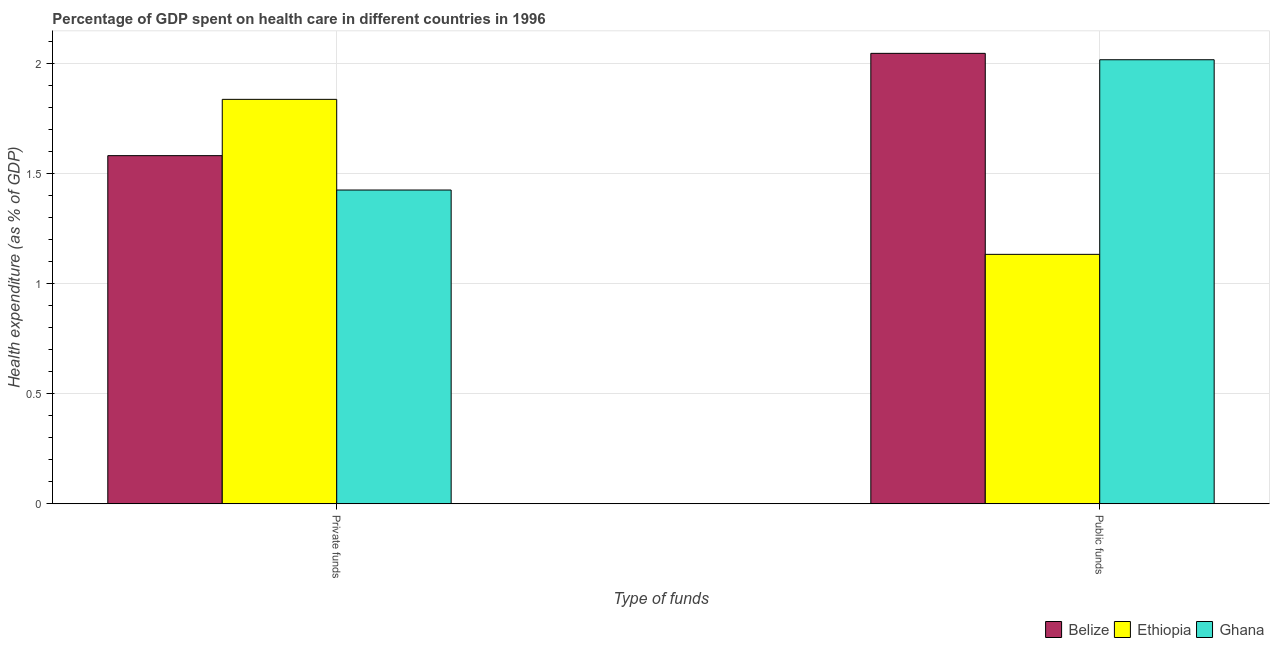How many groups of bars are there?
Your response must be concise. 2. Are the number of bars per tick equal to the number of legend labels?
Make the answer very short. Yes. How many bars are there on the 2nd tick from the left?
Your response must be concise. 3. What is the label of the 2nd group of bars from the left?
Your answer should be compact. Public funds. What is the amount of private funds spent in healthcare in Ghana?
Ensure brevity in your answer.  1.43. Across all countries, what is the maximum amount of private funds spent in healthcare?
Offer a very short reply. 1.84. Across all countries, what is the minimum amount of public funds spent in healthcare?
Ensure brevity in your answer.  1.13. In which country was the amount of private funds spent in healthcare maximum?
Keep it short and to the point. Ethiopia. In which country was the amount of private funds spent in healthcare minimum?
Provide a short and direct response. Ghana. What is the total amount of public funds spent in healthcare in the graph?
Offer a terse response. 5.2. What is the difference between the amount of private funds spent in healthcare in Belize and that in Ethiopia?
Your answer should be very brief. -0.26. What is the difference between the amount of private funds spent in healthcare in Belize and the amount of public funds spent in healthcare in Ghana?
Provide a short and direct response. -0.44. What is the average amount of private funds spent in healthcare per country?
Offer a very short reply. 1.62. What is the difference between the amount of private funds spent in healthcare and amount of public funds spent in healthcare in Ethiopia?
Your answer should be very brief. 0.7. What is the ratio of the amount of private funds spent in healthcare in Ethiopia to that in Ghana?
Give a very brief answer. 1.29. Is the amount of public funds spent in healthcare in Ethiopia less than that in Belize?
Provide a short and direct response. Yes. What does the 3rd bar from the left in Private funds represents?
Keep it short and to the point. Ghana. What does the 1st bar from the right in Private funds represents?
Give a very brief answer. Ghana. What is the difference between two consecutive major ticks on the Y-axis?
Your response must be concise. 0.5. Where does the legend appear in the graph?
Your answer should be compact. Bottom right. What is the title of the graph?
Your response must be concise. Percentage of GDP spent on health care in different countries in 1996. Does "Tanzania" appear as one of the legend labels in the graph?
Ensure brevity in your answer.  No. What is the label or title of the X-axis?
Give a very brief answer. Type of funds. What is the label or title of the Y-axis?
Ensure brevity in your answer.  Health expenditure (as % of GDP). What is the Health expenditure (as % of GDP) in Belize in Private funds?
Your answer should be very brief. 1.58. What is the Health expenditure (as % of GDP) of Ethiopia in Private funds?
Make the answer very short. 1.84. What is the Health expenditure (as % of GDP) of Ghana in Private funds?
Provide a succinct answer. 1.43. What is the Health expenditure (as % of GDP) of Belize in Public funds?
Offer a terse response. 2.05. What is the Health expenditure (as % of GDP) of Ethiopia in Public funds?
Offer a terse response. 1.13. What is the Health expenditure (as % of GDP) of Ghana in Public funds?
Keep it short and to the point. 2.02. Across all Type of funds, what is the maximum Health expenditure (as % of GDP) of Belize?
Your answer should be compact. 2.05. Across all Type of funds, what is the maximum Health expenditure (as % of GDP) of Ethiopia?
Your answer should be very brief. 1.84. Across all Type of funds, what is the maximum Health expenditure (as % of GDP) in Ghana?
Your answer should be compact. 2.02. Across all Type of funds, what is the minimum Health expenditure (as % of GDP) of Belize?
Your answer should be compact. 1.58. Across all Type of funds, what is the minimum Health expenditure (as % of GDP) in Ethiopia?
Keep it short and to the point. 1.13. Across all Type of funds, what is the minimum Health expenditure (as % of GDP) in Ghana?
Give a very brief answer. 1.43. What is the total Health expenditure (as % of GDP) of Belize in the graph?
Provide a short and direct response. 3.63. What is the total Health expenditure (as % of GDP) of Ethiopia in the graph?
Offer a very short reply. 2.97. What is the total Health expenditure (as % of GDP) of Ghana in the graph?
Offer a very short reply. 3.45. What is the difference between the Health expenditure (as % of GDP) of Belize in Private funds and that in Public funds?
Provide a short and direct response. -0.47. What is the difference between the Health expenditure (as % of GDP) of Ethiopia in Private funds and that in Public funds?
Offer a terse response. 0.7. What is the difference between the Health expenditure (as % of GDP) in Ghana in Private funds and that in Public funds?
Your answer should be compact. -0.59. What is the difference between the Health expenditure (as % of GDP) of Belize in Private funds and the Health expenditure (as % of GDP) of Ethiopia in Public funds?
Your answer should be compact. 0.45. What is the difference between the Health expenditure (as % of GDP) of Belize in Private funds and the Health expenditure (as % of GDP) of Ghana in Public funds?
Your answer should be very brief. -0.44. What is the difference between the Health expenditure (as % of GDP) in Ethiopia in Private funds and the Health expenditure (as % of GDP) in Ghana in Public funds?
Offer a terse response. -0.18. What is the average Health expenditure (as % of GDP) of Belize per Type of funds?
Make the answer very short. 1.82. What is the average Health expenditure (as % of GDP) of Ethiopia per Type of funds?
Make the answer very short. 1.49. What is the average Health expenditure (as % of GDP) in Ghana per Type of funds?
Your answer should be very brief. 1.72. What is the difference between the Health expenditure (as % of GDP) of Belize and Health expenditure (as % of GDP) of Ethiopia in Private funds?
Make the answer very short. -0.26. What is the difference between the Health expenditure (as % of GDP) in Belize and Health expenditure (as % of GDP) in Ghana in Private funds?
Offer a terse response. 0.16. What is the difference between the Health expenditure (as % of GDP) of Ethiopia and Health expenditure (as % of GDP) of Ghana in Private funds?
Provide a succinct answer. 0.41. What is the difference between the Health expenditure (as % of GDP) in Belize and Health expenditure (as % of GDP) in Ethiopia in Public funds?
Keep it short and to the point. 0.91. What is the difference between the Health expenditure (as % of GDP) of Belize and Health expenditure (as % of GDP) of Ghana in Public funds?
Offer a terse response. 0.03. What is the difference between the Health expenditure (as % of GDP) in Ethiopia and Health expenditure (as % of GDP) in Ghana in Public funds?
Give a very brief answer. -0.88. What is the ratio of the Health expenditure (as % of GDP) of Belize in Private funds to that in Public funds?
Your response must be concise. 0.77. What is the ratio of the Health expenditure (as % of GDP) in Ethiopia in Private funds to that in Public funds?
Offer a very short reply. 1.62. What is the ratio of the Health expenditure (as % of GDP) in Ghana in Private funds to that in Public funds?
Your answer should be compact. 0.71. What is the difference between the highest and the second highest Health expenditure (as % of GDP) in Belize?
Make the answer very short. 0.47. What is the difference between the highest and the second highest Health expenditure (as % of GDP) in Ethiopia?
Offer a terse response. 0.7. What is the difference between the highest and the second highest Health expenditure (as % of GDP) in Ghana?
Offer a terse response. 0.59. What is the difference between the highest and the lowest Health expenditure (as % of GDP) in Belize?
Make the answer very short. 0.47. What is the difference between the highest and the lowest Health expenditure (as % of GDP) in Ethiopia?
Provide a short and direct response. 0.7. What is the difference between the highest and the lowest Health expenditure (as % of GDP) in Ghana?
Keep it short and to the point. 0.59. 